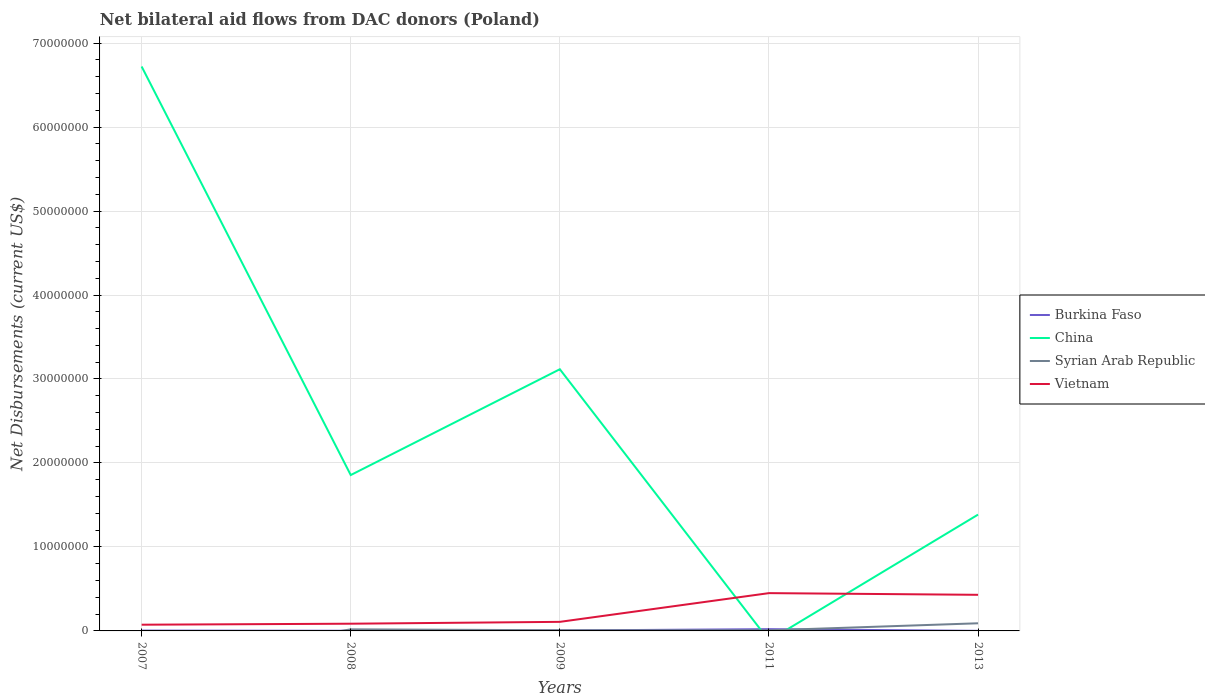How many different coloured lines are there?
Provide a short and direct response. 4. Is the number of lines equal to the number of legend labels?
Keep it short and to the point. No. Across all years, what is the maximum net bilateral aid flows in Vietnam?
Offer a terse response. 7.40e+05. What is the difference between the highest and the second highest net bilateral aid flows in Vietnam?
Offer a terse response. 3.76e+06. What is the difference between the highest and the lowest net bilateral aid flows in China?
Keep it short and to the point. 2. How many lines are there?
Offer a very short reply. 4. What is the difference between two consecutive major ticks on the Y-axis?
Make the answer very short. 1.00e+07. Are the values on the major ticks of Y-axis written in scientific E-notation?
Your answer should be very brief. No. Does the graph contain grids?
Give a very brief answer. Yes. Where does the legend appear in the graph?
Provide a short and direct response. Center right. How many legend labels are there?
Provide a short and direct response. 4. What is the title of the graph?
Keep it short and to the point. Net bilateral aid flows from DAC donors (Poland). Does "Malaysia" appear as one of the legend labels in the graph?
Your answer should be compact. No. What is the label or title of the X-axis?
Offer a very short reply. Years. What is the label or title of the Y-axis?
Offer a very short reply. Net Disbursements (current US$). What is the Net Disbursements (current US$) in China in 2007?
Your answer should be compact. 6.72e+07. What is the Net Disbursements (current US$) of Syrian Arab Republic in 2007?
Give a very brief answer. 0. What is the Net Disbursements (current US$) of Vietnam in 2007?
Provide a succinct answer. 7.40e+05. What is the Net Disbursements (current US$) in Burkina Faso in 2008?
Offer a terse response. 2.00e+04. What is the Net Disbursements (current US$) of China in 2008?
Provide a short and direct response. 1.86e+07. What is the Net Disbursements (current US$) of Vietnam in 2008?
Your answer should be very brief. 8.60e+05. What is the Net Disbursements (current US$) of Burkina Faso in 2009?
Your response must be concise. 5.00e+04. What is the Net Disbursements (current US$) of China in 2009?
Provide a short and direct response. 3.12e+07. What is the Net Disbursements (current US$) of Syrian Arab Republic in 2009?
Offer a very short reply. 8.00e+04. What is the Net Disbursements (current US$) in Vietnam in 2009?
Your answer should be compact. 1.08e+06. What is the Net Disbursements (current US$) of Burkina Faso in 2011?
Give a very brief answer. 2.10e+05. What is the Net Disbursements (current US$) of China in 2011?
Your answer should be compact. 0. What is the Net Disbursements (current US$) in Vietnam in 2011?
Make the answer very short. 4.50e+06. What is the Net Disbursements (current US$) of China in 2013?
Your response must be concise. 1.38e+07. What is the Net Disbursements (current US$) in Syrian Arab Republic in 2013?
Give a very brief answer. 9.10e+05. What is the Net Disbursements (current US$) in Vietnam in 2013?
Provide a short and direct response. 4.30e+06. Across all years, what is the maximum Net Disbursements (current US$) in Burkina Faso?
Offer a very short reply. 2.10e+05. Across all years, what is the maximum Net Disbursements (current US$) of China?
Offer a terse response. 6.72e+07. Across all years, what is the maximum Net Disbursements (current US$) in Syrian Arab Republic?
Make the answer very short. 9.10e+05. Across all years, what is the maximum Net Disbursements (current US$) in Vietnam?
Provide a short and direct response. 4.50e+06. Across all years, what is the minimum Net Disbursements (current US$) in Burkina Faso?
Keep it short and to the point. 10000. Across all years, what is the minimum Net Disbursements (current US$) in China?
Your answer should be compact. 0. Across all years, what is the minimum Net Disbursements (current US$) in Syrian Arab Republic?
Offer a terse response. 0. Across all years, what is the minimum Net Disbursements (current US$) in Vietnam?
Your response must be concise. 7.40e+05. What is the total Net Disbursements (current US$) of Burkina Faso in the graph?
Offer a terse response. 3.30e+05. What is the total Net Disbursements (current US$) in China in the graph?
Make the answer very short. 1.31e+08. What is the total Net Disbursements (current US$) in Syrian Arab Republic in the graph?
Give a very brief answer. 1.25e+06. What is the total Net Disbursements (current US$) in Vietnam in the graph?
Give a very brief answer. 1.15e+07. What is the difference between the Net Disbursements (current US$) in Burkina Faso in 2007 and that in 2008?
Keep it short and to the point. 2.00e+04. What is the difference between the Net Disbursements (current US$) in China in 2007 and that in 2008?
Your response must be concise. 4.86e+07. What is the difference between the Net Disbursements (current US$) of Vietnam in 2007 and that in 2008?
Your answer should be compact. -1.20e+05. What is the difference between the Net Disbursements (current US$) of China in 2007 and that in 2009?
Make the answer very short. 3.60e+07. What is the difference between the Net Disbursements (current US$) of Vietnam in 2007 and that in 2009?
Give a very brief answer. -3.40e+05. What is the difference between the Net Disbursements (current US$) of Burkina Faso in 2007 and that in 2011?
Keep it short and to the point. -1.70e+05. What is the difference between the Net Disbursements (current US$) in Vietnam in 2007 and that in 2011?
Your answer should be compact. -3.76e+06. What is the difference between the Net Disbursements (current US$) of Burkina Faso in 2007 and that in 2013?
Keep it short and to the point. 3.00e+04. What is the difference between the Net Disbursements (current US$) in China in 2007 and that in 2013?
Keep it short and to the point. 5.34e+07. What is the difference between the Net Disbursements (current US$) in Vietnam in 2007 and that in 2013?
Your answer should be very brief. -3.56e+06. What is the difference between the Net Disbursements (current US$) in China in 2008 and that in 2009?
Your answer should be compact. -1.26e+07. What is the difference between the Net Disbursements (current US$) in Syrian Arab Republic in 2008 and that in 2009?
Keep it short and to the point. 1.10e+05. What is the difference between the Net Disbursements (current US$) of Vietnam in 2008 and that in 2009?
Your response must be concise. -2.20e+05. What is the difference between the Net Disbursements (current US$) of Burkina Faso in 2008 and that in 2011?
Ensure brevity in your answer.  -1.90e+05. What is the difference between the Net Disbursements (current US$) in Syrian Arab Republic in 2008 and that in 2011?
Make the answer very short. 1.20e+05. What is the difference between the Net Disbursements (current US$) of Vietnam in 2008 and that in 2011?
Give a very brief answer. -3.64e+06. What is the difference between the Net Disbursements (current US$) in China in 2008 and that in 2013?
Ensure brevity in your answer.  4.71e+06. What is the difference between the Net Disbursements (current US$) of Syrian Arab Republic in 2008 and that in 2013?
Provide a short and direct response. -7.20e+05. What is the difference between the Net Disbursements (current US$) of Vietnam in 2008 and that in 2013?
Make the answer very short. -3.44e+06. What is the difference between the Net Disbursements (current US$) of Burkina Faso in 2009 and that in 2011?
Ensure brevity in your answer.  -1.60e+05. What is the difference between the Net Disbursements (current US$) in Syrian Arab Republic in 2009 and that in 2011?
Your answer should be very brief. 10000. What is the difference between the Net Disbursements (current US$) in Vietnam in 2009 and that in 2011?
Give a very brief answer. -3.42e+06. What is the difference between the Net Disbursements (current US$) of China in 2009 and that in 2013?
Offer a very short reply. 1.73e+07. What is the difference between the Net Disbursements (current US$) in Syrian Arab Republic in 2009 and that in 2013?
Your answer should be very brief. -8.30e+05. What is the difference between the Net Disbursements (current US$) in Vietnam in 2009 and that in 2013?
Your answer should be compact. -3.22e+06. What is the difference between the Net Disbursements (current US$) of Burkina Faso in 2011 and that in 2013?
Your answer should be very brief. 2.00e+05. What is the difference between the Net Disbursements (current US$) of Syrian Arab Republic in 2011 and that in 2013?
Your answer should be very brief. -8.40e+05. What is the difference between the Net Disbursements (current US$) of Burkina Faso in 2007 and the Net Disbursements (current US$) of China in 2008?
Make the answer very short. -1.85e+07. What is the difference between the Net Disbursements (current US$) of Burkina Faso in 2007 and the Net Disbursements (current US$) of Syrian Arab Republic in 2008?
Your response must be concise. -1.50e+05. What is the difference between the Net Disbursements (current US$) in Burkina Faso in 2007 and the Net Disbursements (current US$) in Vietnam in 2008?
Ensure brevity in your answer.  -8.20e+05. What is the difference between the Net Disbursements (current US$) of China in 2007 and the Net Disbursements (current US$) of Syrian Arab Republic in 2008?
Offer a very short reply. 6.70e+07. What is the difference between the Net Disbursements (current US$) of China in 2007 and the Net Disbursements (current US$) of Vietnam in 2008?
Keep it short and to the point. 6.64e+07. What is the difference between the Net Disbursements (current US$) of Burkina Faso in 2007 and the Net Disbursements (current US$) of China in 2009?
Offer a terse response. -3.11e+07. What is the difference between the Net Disbursements (current US$) of Burkina Faso in 2007 and the Net Disbursements (current US$) of Vietnam in 2009?
Offer a very short reply. -1.04e+06. What is the difference between the Net Disbursements (current US$) in China in 2007 and the Net Disbursements (current US$) in Syrian Arab Republic in 2009?
Offer a very short reply. 6.71e+07. What is the difference between the Net Disbursements (current US$) in China in 2007 and the Net Disbursements (current US$) in Vietnam in 2009?
Make the answer very short. 6.61e+07. What is the difference between the Net Disbursements (current US$) in Burkina Faso in 2007 and the Net Disbursements (current US$) in Syrian Arab Republic in 2011?
Provide a succinct answer. -3.00e+04. What is the difference between the Net Disbursements (current US$) in Burkina Faso in 2007 and the Net Disbursements (current US$) in Vietnam in 2011?
Keep it short and to the point. -4.46e+06. What is the difference between the Net Disbursements (current US$) in China in 2007 and the Net Disbursements (current US$) in Syrian Arab Republic in 2011?
Keep it short and to the point. 6.71e+07. What is the difference between the Net Disbursements (current US$) of China in 2007 and the Net Disbursements (current US$) of Vietnam in 2011?
Offer a terse response. 6.27e+07. What is the difference between the Net Disbursements (current US$) of Burkina Faso in 2007 and the Net Disbursements (current US$) of China in 2013?
Offer a very short reply. -1.38e+07. What is the difference between the Net Disbursements (current US$) in Burkina Faso in 2007 and the Net Disbursements (current US$) in Syrian Arab Republic in 2013?
Offer a terse response. -8.70e+05. What is the difference between the Net Disbursements (current US$) in Burkina Faso in 2007 and the Net Disbursements (current US$) in Vietnam in 2013?
Keep it short and to the point. -4.26e+06. What is the difference between the Net Disbursements (current US$) of China in 2007 and the Net Disbursements (current US$) of Syrian Arab Republic in 2013?
Give a very brief answer. 6.63e+07. What is the difference between the Net Disbursements (current US$) of China in 2007 and the Net Disbursements (current US$) of Vietnam in 2013?
Offer a terse response. 6.29e+07. What is the difference between the Net Disbursements (current US$) of Burkina Faso in 2008 and the Net Disbursements (current US$) of China in 2009?
Provide a succinct answer. -3.11e+07. What is the difference between the Net Disbursements (current US$) of Burkina Faso in 2008 and the Net Disbursements (current US$) of Syrian Arab Republic in 2009?
Make the answer very short. -6.00e+04. What is the difference between the Net Disbursements (current US$) of Burkina Faso in 2008 and the Net Disbursements (current US$) of Vietnam in 2009?
Give a very brief answer. -1.06e+06. What is the difference between the Net Disbursements (current US$) of China in 2008 and the Net Disbursements (current US$) of Syrian Arab Republic in 2009?
Provide a short and direct response. 1.85e+07. What is the difference between the Net Disbursements (current US$) in China in 2008 and the Net Disbursements (current US$) in Vietnam in 2009?
Give a very brief answer. 1.75e+07. What is the difference between the Net Disbursements (current US$) of Syrian Arab Republic in 2008 and the Net Disbursements (current US$) of Vietnam in 2009?
Provide a short and direct response. -8.90e+05. What is the difference between the Net Disbursements (current US$) of Burkina Faso in 2008 and the Net Disbursements (current US$) of Vietnam in 2011?
Offer a terse response. -4.48e+06. What is the difference between the Net Disbursements (current US$) of China in 2008 and the Net Disbursements (current US$) of Syrian Arab Republic in 2011?
Ensure brevity in your answer.  1.85e+07. What is the difference between the Net Disbursements (current US$) of China in 2008 and the Net Disbursements (current US$) of Vietnam in 2011?
Your response must be concise. 1.41e+07. What is the difference between the Net Disbursements (current US$) of Syrian Arab Republic in 2008 and the Net Disbursements (current US$) of Vietnam in 2011?
Your response must be concise. -4.31e+06. What is the difference between the Net Disbursements (current US$) of Burkina Faso in 2008 and the Net Disbursements (current US$) of China in 2013?
Your answer should be very brief. -1.38e+07. What is the difference between the Net Disbursements (current US$) of Burkina Faso in 2008 and the Net Disbursements (current US$) of Syrian Arab Republic in 2013?
Offer a terse response. -8.90e+05. What is the difference between the Net Disbursements (current US$) in Burkina Faso in 2008 and the Net Disbursements (current US$) in Vietnam in 2013?
Your answer should be very brief. -4.28e+06. What is the difference between the Net Disbursements (current US$) in China in 2008 and the Net Disbursements (current US$) in Syrian Arab Republic in 2013?
Provide a short and direct response. 1.76e+07. What is the difference between the Net Disbursements (current US$) of China in 2008 and the Net Disbursements (current US$) of Vietnam in 2013?
Offer a terse response. 1.43e+07. What is the difference between the Net Disbursements (current US$) of Syrian Arab Republic in 2008 and the Net Disbursements (current US$) of Vietnam in 2013?
Make the answer very short. -4.11e+06. What is the difference between the Net Disbursements (current US$) in Burkina Faso in 2009 and the Net Disbursements (current US$) in Vietnam in 2011?
Provide a short and direct response. -4.45e+06. What is the difference between the Net Disbursements (current US$) of China in 2009 and the Net Disbursements (current US$) of Syrian Arab Republic in 2011?
Your response must be concise. 3.11e+07. What is the difference between the Net Disbursements (current US$) in China in 2009 and the Net Disbursements (current US$) in Vietnam in 2011?
Provide a short and direct response. 2.67e+07. What is the difference between the Net Disbursements (current US$) of Syrian Arab Republic in 2009 and the Net Disbursements (current US$) of Vietnam in 2011?
Ensure brevity in your answer.  -4.42e+06. What is the difference between the Net Disbursements (current US$) of Burkina Faso in 2009 and the Net Disbursements (current US$) of China in 2013?
Offer a terse response. -1.38e+07. What is the difference between the Net Disbursements (current US$) of Burkina Faso in 2009 and the Net Disbursements (current US$) of Syrian Arab Republic in 2013?
Your answer should be compact. -8.60e+05. What is the difference between the Net Disbursements (current US$) in Burkina Faso in 2009 and the Net Disbursements (current US$) in Vietnam in 2013?
Ensure brevity in your answer.  -4.25e+06. What is the difference between the Net Disbursements (current US$) of China in 2009 and the Net Disbursements (current US$) of Syrian Arab Republic in 2013?
Make the answer very short. 3.02e+07. What is the difference between the Net Disbursements (current US$) in China in 2009 and the Net Disbursements (current US$) in Vietnam in 2013?
Keep it short and to the point. 2.69e+07. What is the difference between the Net Disbursements (current US$) of Syrian Arab Republic in 2009 and the Net Disbursements (current US$) of Vietnam in 2013?
Your answer should be very brief. -4.22e+06. What is the difference between the Net Disbursements (current US$) in Burkina Faso in 2011 and the Net Disbursements (current US$) in China in 2013?
Give a very brief answer. -1.36e+07. What is the difference between the Net Disbursements (current US$) in Burkina Faso in 2011 and the Net Disbursements (current US$) in Syrian Arab Republic in 2013?
Your response must be concise. -7.00e+05. What is the difference between the Net Disbursements (current US$) in Burkina Faso in 2011 and the Net Disbursements (current US$) in Vietnam in 2013?
Your response must be concise. -4.09e+06. What is the difference between the Net Disbursements (current US$) of Syrian Arab Republic in 2011 and the Net Disbursements (current US$) of Vietnam in 2013?
Your response must be concise. -4.23e+06. What is the average Net Disbursements (current US$) of Burkina Faso per year?
Ensure brevity in your answer.  6.60e+04. What is the average Net Disbursements (current US$) in China per year?
Provide a short and direct response. 2.62e+07. What is the average Net Disbursements (current US$) of Syrian Arab Republic per year?
Give a very brief answer. 2.50e+05. What is the average Net Disbursements (current US$) of Vietnam per year?
Provide a succinct answer. 2.30e+06. In the year 2007, what is the difference between the Net Disbursements (current US$) of Burkina Faso and Net Disbursements (current US$) of China?
Your answer should be very brief. -6.72e+07. In the year 2007, what is the difference between the Net Disbursements (current US$) of Burkina Faso and Net Disbursements (current US$) of Vietnam?
Make the answer very short. -7.00e+05. In the year 2007, what is the difference between the Net Disbursements (current US$) of China and Net Disbursements (current US$) of Vietnam?
Offer a very short reply. 6.65e+07. In the year 2008, what is the difference between the Net Disbursements (current US$) of Burkina Faso and Net Disbursements (current US$) of China?
Offer a very short reply. -1.85e+07. In the year 2008, what is the difference between the Net Disbursements (current US$) in Burkina Faso and Net Disbursements (current US$) in Syrian Arab Republic?
Provide a succinct answer. -1.70e+05. In the year 2008, what is the difference between the Net Disbursements (current US$) in Burkina Faso and Net Disbursements (current US$) in Vietnam?
Provide a short and direct response. -8.40e+05. In the year 2008, what is the difference between the Net Disbursements (current US$) of China and Net Disbursements (current US$) of Syrian Arab Republic?
Your answer should be very brief. 1.84e+07. In the year 2008, what is the difference between the Net Disbursements (current US$) in China and Net Disbursements (current US$) in Vietnam?
Your answer should be very brief. 1.77e+07. In the year 2008, what is the difference between the Net Disbursements (current US$) in Syrian Arab Republic and Net Disbursements (current US$) in Vietnam?
Keep it short and to the point. -6.70e+05. In the year 2009, what is the difference between the Net Disbursements (current US$) of Burkina Faso and Net Disbursements (current US$) of China?
Your response must be concise. -3.11e+07. In the year 2009, what is the difference between the Net Disbursements (current US$) of Burkina Faso and Net Disbursements (current US$) of Syrian Arab Republic?
Provide a short and direct response. -3.00e+04. In the year 2009, what is the difference between the Net Disbursements (current US$) in Burkina Faso and Net Disbursements (current US$) in Vietnam?
Make the answer very short. -1.03e+06. In the year 2009, what is the difference between the Net Disbursements (current US$) in China and Net Disbursements (current US$) in Syrian Arab Republic?
Offer a very short reply. 3.11e+07. In the year 2009, what is the difference between the Net Disbursements (current US$) of China and Net Disbursements (current US$) of Vietnam?
Give a very brief answer. 3.01e+07. In the year 2009, what is the difference between the Net Disbursements (current US$) in Syrian Arab Republic and Net Disbursements (current US$) in Vietnam?
Give a very brief answer. -1.00e+06. In the year 2011, what is the difference between the Net Disbursements (current US$) of Burkina Faso and Net Disbursements (current US$) of Vietnam?
Make the answer very short. -4.29e+06. In the year 2011, what is the difference between the Net Disbursements (current US$) in Syrian Arab Republic and Net Disbursements (current US$) in Vietnam?
Offer a terse response. -4.43e+06. In the year 2013, what is the difference between the Net Disbursements (current US$) of Burkina Faso and Net Disbursements (current US$) of China?
Keep it short and to the point. -1.38e+07. In the year 2013, what is the difference between the Net Disbursements (current US$) in Burkina Faso and Net Disbursements (current US$) in Syrian Arab Republic?
Provide a short and direct response. -9.00e+05. In the year 2013, what is the difference between the Net Disbursements (current US$) of Burkina Faso and Net Disbursements (current US$) of Vietnam?
Keep it short and to the point. -4.29e+06. In the year 2013, what is the difference between the Net Disbursements (current US$) in China and Net Disbursements (current US$) in Syrian Arab Republic?
Offer a terse response. 1.29e+07. In the year 2013, what is the difference between the Net Disbursements (current US$) in China and Net Disbursements (current US$) in Vietnam?
Provide a succinct answer. 9.55e+06. In the year 2013, what is the difference between the Net Disbursements (current US$) in Syrian Arab Republic and Net Disbursements (current US$) in Vietnam?
Give a very brief answer. -3.39e+06. What is the ratio of the Net Disbursements (current US$) in China in 2007 to that in 2008?
Make the answer very short. 3.62. What is the ratio of the Net Disbursements (current US$) in Vietnam in 2007 to that in 2008?
Offer a terse response. 0.86. What is the ratio of the Net Disbursements (current US$) in Burkina Faso in 2007 to that in 2009?
Ensure brevity in your answer.  0.8. What is the ratio of the Net Disbursements (current US$) in China in 2007 to that in 2009?
Give a very brief answer. 2.16. What is the ratio of the Net Disbursements (current US$) in Vietnam in 2007 to that in 2009?
Offer a very short reply. 0.69. What is the ratio of the Net Disbursements (current US$) of Burkina Faso in 2007 to that in 2011?
Provide a short and direct response. 0.19. What is the ratio of the Net Disbursements (current US$) in Vietnam in 2007 to that in 2011?
Give a very brief answer. 0.16. What is the ratio of the Net Disbursements (current US$) in Burkina Faso in 2007 to that in 2013?
Your response must be concise. 4. What is the ratio of the Net Disbursements (current US$) of China in 2007 to that in 2013?
Provide a succinct answer. 4.85. What is the ratio of the Net Disbursements (current US$) in Vietnam in 2007 to that in 2013?
Ensure brevity in your answer.  0.17. What is the ratio of the Net Disbursements (current US$) in Burkina Faso in 2008 to that in 2009?
Offer a terse response. 0.4. What is the ratio of the Net Disbursements (current US$) of China in 2008 to that in 2009?
Provide a succinct answer. 0.6. What is the ratio of the Net Disbursements (current US$) in Syrian Arab Republic in 2008 to that in 2009?
Keep it short and to the point. 2.38. What is the ratio of the Net Disbursements (current US$) in Vietnam in 2008 to that in 2009?
Provide a short and direct response. 0.8. What is the ratio of the Net Disbursements (current US$) in Burkina Faso in 2008 to that in 2011?
Provide a succinct answer. 0.1. What is the ratio of the Net Disbursements (current US$) in Syrian Arab Republic in 2008 to that in 2011?
Offer a very short reply. 2.71. What is the ratio of the Net Disbursements (current US$) in Vietnam in 2008 to that in 2011?
Provide a succinct answer. 0.19. What is the ratio of the Net Disbursements (current US$) of Burkina Faso in 2008 to that in 2013?
Make the answer very short. 2. What is the ratio of the Net Disbursements (current US$) of China in 2008 to that in 2013?
Make the answer very short. 1.34. What is the ratio of the Net Disbursements (current US$) in Syrian Arab Republic in 2008 to that in 2013?
Provide a short and direct response. 0.21. What is the ratio of the Net Disbursements (current US$) of Vietnam in 2008 to that in 2013?
Your response must be concise. 0.2. What is the ratio of the Net Disbursements (current US$) in Burkina Faso in 2009 to that in 2011?
Your response must be concise. 0.24. What is the ratio of the Net Disbursements (current US$) of Vietnam in 2009 to that in 2011?
Your answer should be compact. 0.24. What is the ratio of the Net Disbursements (current US$) in Burkina Faso in 2009 to that in 2013?
Your response must be concise. 5. What is the ratio of the Net Disbursements (current US$) in China in 2009 to that in 2013?
Your answer should be very brief. 2.25. What is the ratio of the Net Disbursements (current US$) of Syrian Arab Republic in 2009 to that in 2013?
Provide a succinct answer. 0.09. What is the ratio of the Net Disbursements (current US$) in Vietnam in 2009 to that in 2013?
Provide a succinct answer. 0.25. What is the ratio of the Net Disbursements (current US$) of Burkina Faso in 2011 to that in 2013?
Offer a terse response. 21. What is the ratio of the Net Disbursements (current US$) of Syrian Arab Republic in 2011 to that in 2013?
Your response must be concise. 0.08. What is the ratio of the Net Disbursements (current US$) in Vietnam in 2011 to that in 2013?
Provide a succinct answer. 1.05. What is the difference between the highest and the second highest Net Disbursements (current US$) of China?
Provide a succinct answer. 3.60e+07. What is the difference between the highest and the second highest Net Disbursements (current US$) of Syrian Arab Republic?
Ensure brevity in your answer.  7.20e+05. What is the difference between the highest and the lowest Net Disbursements (current US$) in China?
Offer a very short reply. 6.72e+07. What is the difference between the highest and the lowest Net Disbursements (current US$) in Syrian Arab Republic?
Give a very brief answer. 9.10e+05. What is the difference between the highest and the lowest Net Disbursements (current US$) in Vietnam?
Provide a succinct answer. 3.76e+06. 